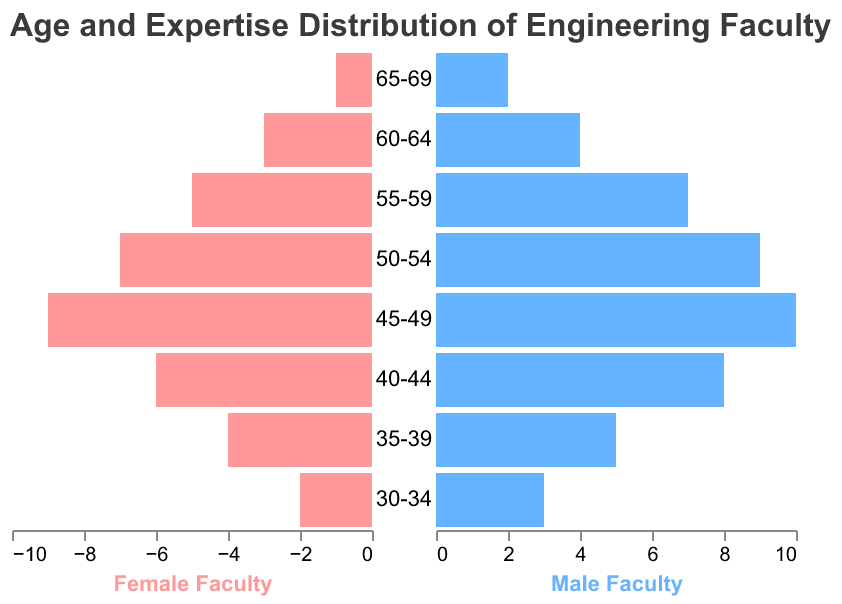What's the title of the plot? The title of the plot is located at the top of the figure, providing a summary of what the visual represents. The title is "Age and Expertise Distribution of Engineering Faculty."
Answer: Age and Expertise Distribution of Engineering Faculty How many female faculty members are aged 45-49? To find the number of female faculty members aged 45-49, look for the corresponding age group on the y-axis, then follow the bar to see its length, which represents the count. In this case, the bar for the age group 45-49 extends to 9.
Answer: 9 In which age group do male faculty members reach their highest count? To determine this, identify the age group with the longest bar on the right-hand side (colored in light blue). The age group 45-49 has the longest bar, indicating the maximum count.
Answer: 45-49 How many total faculty members (both male and female) are aged 40-44? To find the total number of faculty members aged 40-44, add the counts for both female and male faculty in that age group. Female faculty count is 6, and male faculty count is 8. Therefore, the total is 6 + 8 = 14.
Answer: 14 What is the difference between the number of female faculty members aged 55-59 and those aged 35-39? First, find the female faculty count for both age groups: 5 for 55-59 and 4 for 35-39. Subtract the latter from the former to get the difference: 5 - 4 = 1.
Answer: 1 Compare the number of male faculty members aged 50-54 with those aged 55-59. Which group is larger and by how much? Find the male faculty counts for the two age groups: 9 for 50-54 and 7 for 55-59. Subtract the smaller number from the larger one to find out by how much the larger group exceeds the smaller one: 9 - 7 = 2. Therefore, the 50-54 group is larger by 2.
Answer: 50-54; 2 Which gender has more faculty members in the age group 60-64? Compare the length of the bars for both genders in the age group 60-64. The male faculty have a bar extending to 4, while the female faculty have a bar extending to 3. This indicates that there are more male faculty members.
Answer: Male What is the average number of faculty members (male and female) in the age group 30-34? To find the average, add the number of female and male faculty members in the age group 30-34 and divide by 2. Female = 2, Male = 3. Calculation: (2 + 3) / 2 = 2.5.
Answer: 2.5 What trend is observable about the distribution of female faculty members across increasing age groups? To observe the trend, examine the lengths of the bars representing female faculty members from the youngest to the oldest age groups. Initially, the count increases, reaching a peak at 45-49, and then progressively decreases.
Answer: Initially increasing, peaking at 45-49, then decreasing Which age group has an equal number of female and male faculty members? To determine this, check each age group to see if the lengths of the bars on both sides are the same. The age group 50-54 has equal numbers of male and female faculty members, both having a count of 9.
Answer: 50-54 